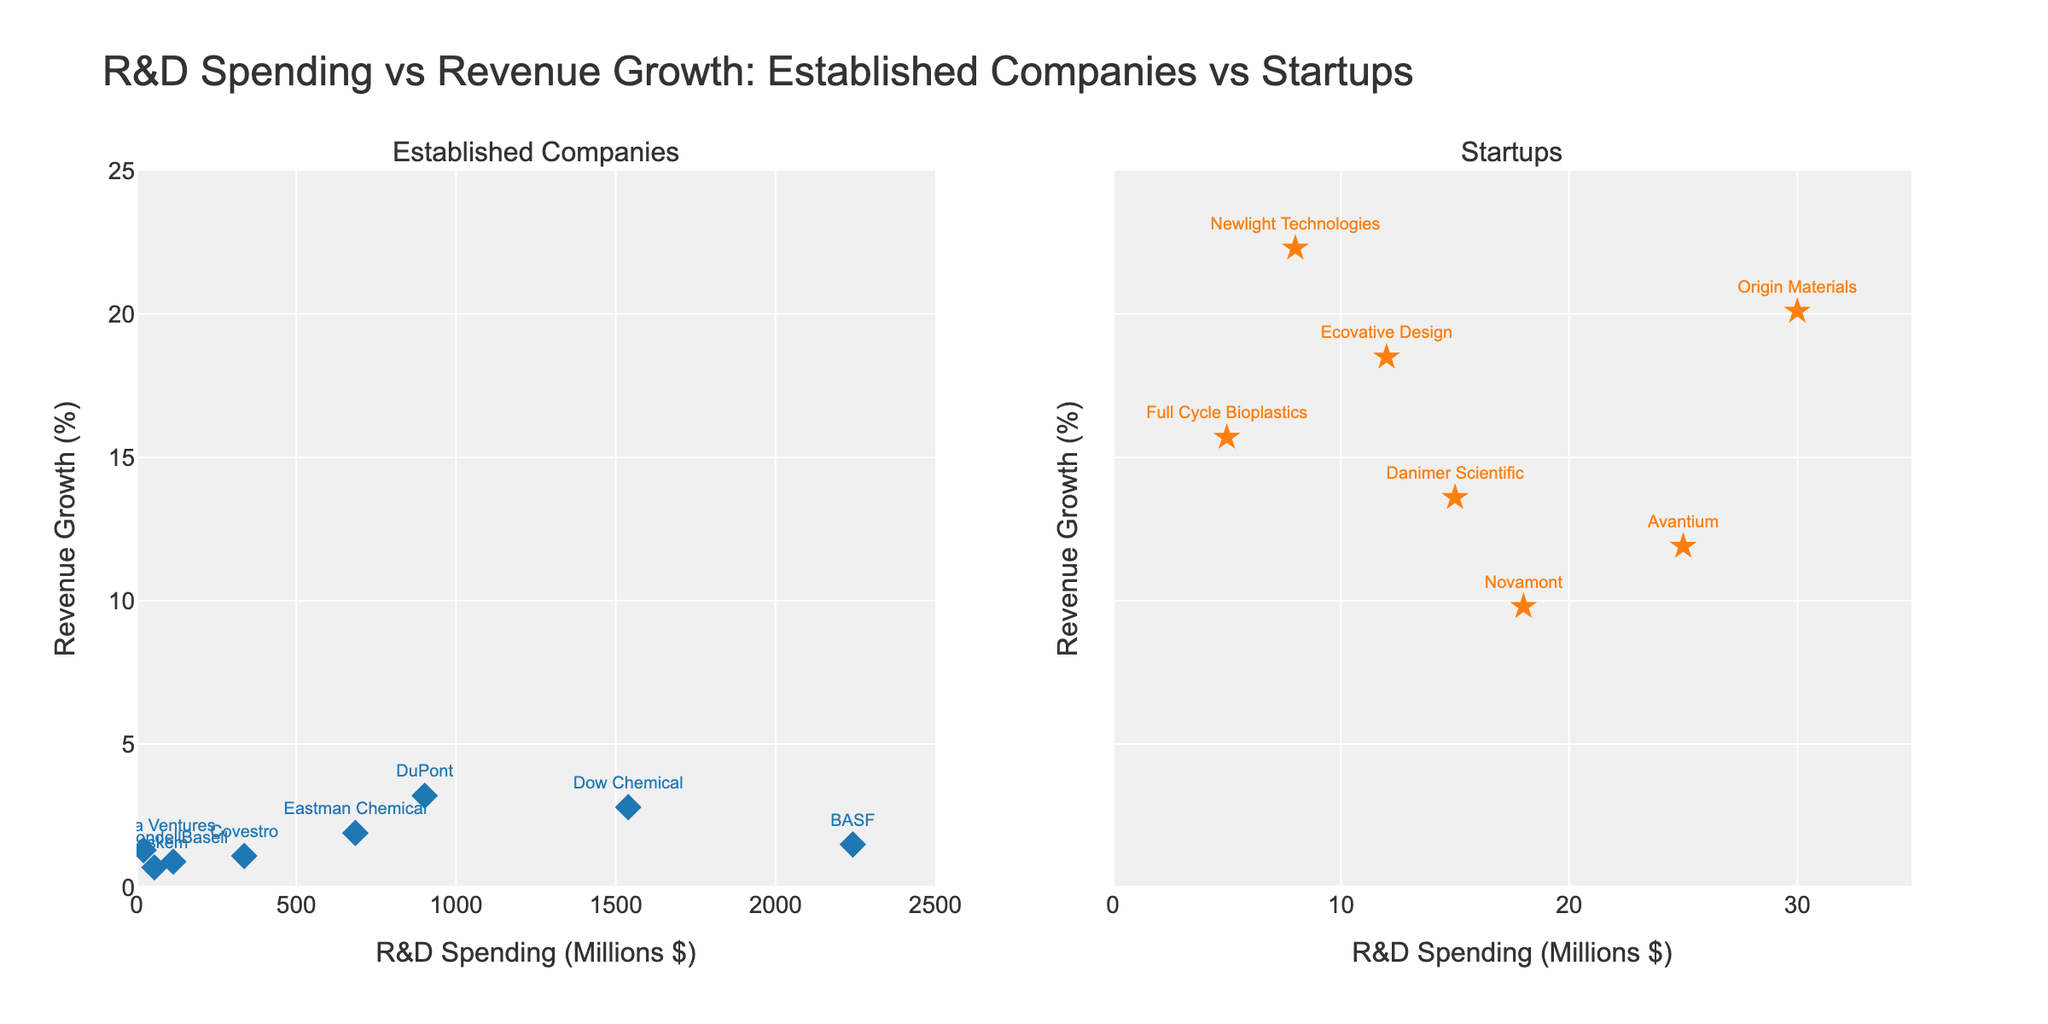What's the title of the figure? The title is located at the top of the figure and summarizes the content, it reads "R&D Spending vs Revenue Growth: Established Companies vs Startups."
Answer: R&D Spending vs Revenue Growth: Established Companies vs Startups Which type of companies has the highest revenue growth percentage? The scatter plot for startups (right subplot) shows points reaching up to nearly 22.3% for Newlight Technologies, whereas the highest revenue growth among the established companies (left subplot) is 3.2% for DuPont.
Answer: Startups What is the range of R&D spending for the startups? The x-axis of the right subplot for startups has a range from 0 to about 35 million dollars.
Answer: 0 to 35 million dollars Which company has the lowest revenue growth percentage among established companies, and what is it? In the left subplot, the data point for Braskem shows the lowest revenue growth at 0.7%.
Answer: Braskem, 0.7% Compare the R&D spending of the company with the highest revenue growth among startups to that of established companies. Newlight Technologies, a startup, has the highest revenue growth at 22.3% with R&D spending of 8 million dollars. DuPont, an established company with the highest revenue growth of 3.2%, spends 902 million dollars.
Answer: 8 million vs. 902 million How does the highest R&D spending among established companies compare to the highest R&D spending among startups? In the left subplot (established companies), BASF has the highest R&D spending at 2242 million dollars. In the right subplot (startups), the highest R&D spending is 30 million dollars by Origin Materials.
Answer: 2242 million vs. 30 million How many startups have an R&D spending greater than 20 million dollars? In the right subplot, two startups have R&D spending above 20 million: Avantium (25 million) and Origin Materials (30 million).
Answer: 2 What is the average revenue growth percentage of startups shown in the figure? The revenue growth percentages for startups are: 18.5, 22.3, 15.7, 11.9, 9.8, 13.6, and 20.1. Adding these up gives 112.9, divided by 7 data points, the average is 112.9/7 = 16.13%.
Answer: 16.13% Which established company has an R&D spending closest to 1000 million dollars? Observing the left subplot, DuPont has an R&D spending of 902 million dollars, which is closest to 1000 million dollars.
Answer: DuPont What is the difference in average revenue growth percentages between startups and established companies? To find the average revenue growth for established companies, sum their percentages: 3.2, 1.5, 2.8, 0.9, 1.1, 0.7, 1.9, 1.3; total = 13.4, average = 13.4/8 = 1.675%. For startups, it's 16.13%. Differences: 16.13% - 1.675% = 14.455%.
Answer: 14.455% 